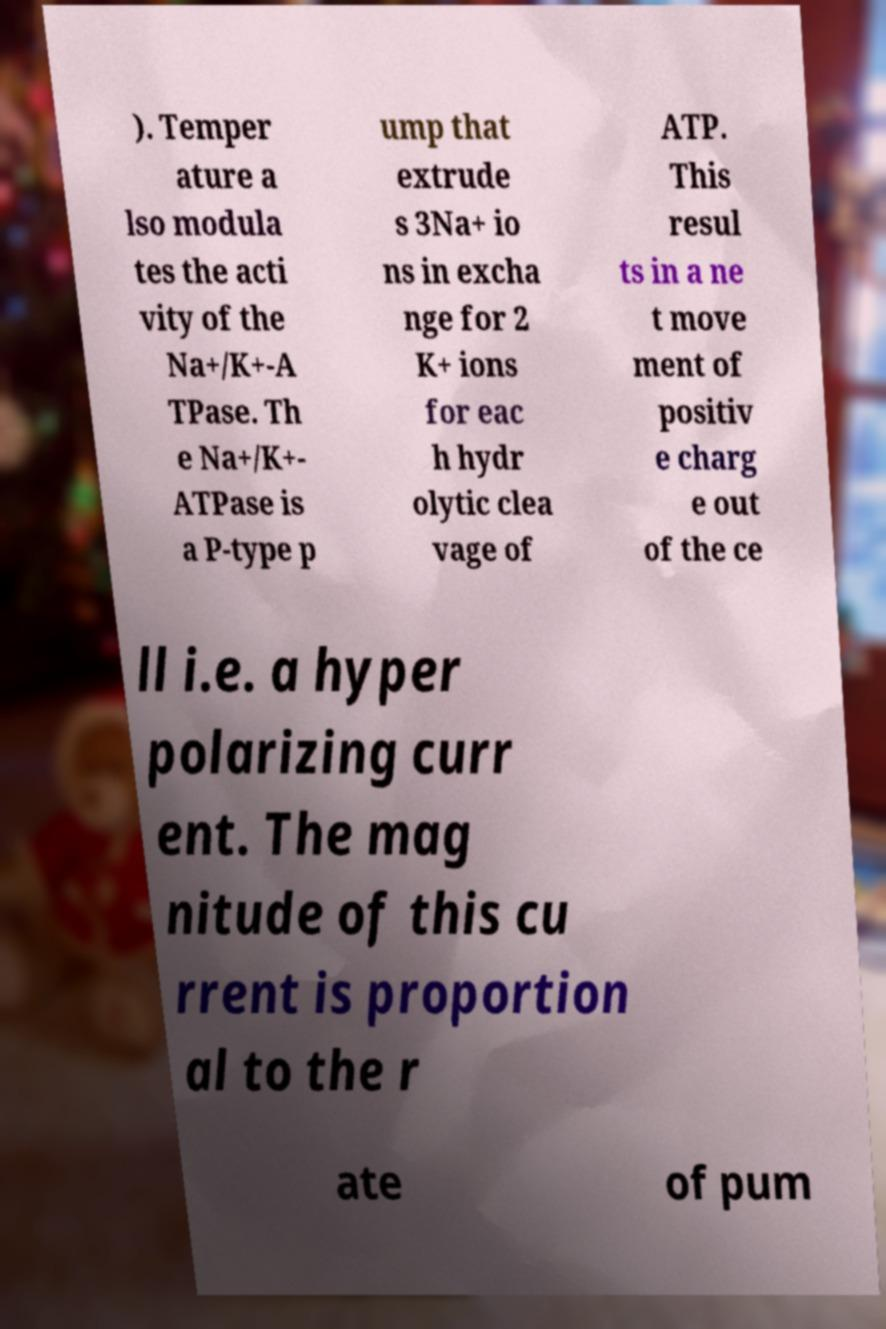Can you accurately transcribe the text from the provided image for me? ). Temper ature a lso modula tes the acti vity of the Na+/K+-A TPase. Th e Na+/K+- ATPase is a P-type p ump that extrude s 3Na+ io ns in excha nge for 2 K+ ions for eac h hydr olytic clea vage of ATP. This resul ts in a ne t move ment of positiv e charg e out of the ce ll i.e. a hyper polarizing curr ent. The mag nitude of this cu rrent is proportion al to the r ate of pum 